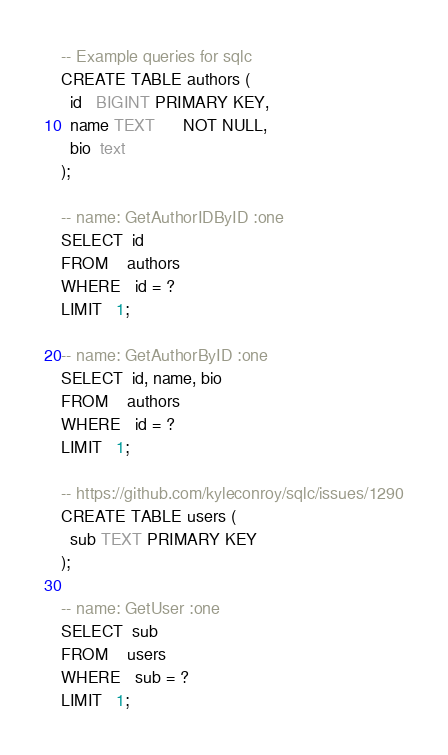<code> <loc_0><loc_0><loc_500><loc_500><_SQL_>-- Example queries for sqlc
CREATE TABLE authors (
  id   BIGINT PRIMARY KEY,
  name TEXT      NOT NULL,
  bio  text
);

-- name: GetAuthorIDByID :one
SELECT  id
FROM    authors
WHERE   id = ?
LIMIT   1;

-- name: GetAuthorByID :one
SELECT  id, name, bio
FROM    authors
WHERE   id = ?
LIMIT   1;

-- https://github.com/kyleconroy/sqlc/issues/1290
CREATE TABLE users (
  sub TEXT PRIMARY KEY
);

-- name: GetUser :one
SELECT  sub
FROM    users
WHERE   sub = ?
LIMIT   1;
</code> 